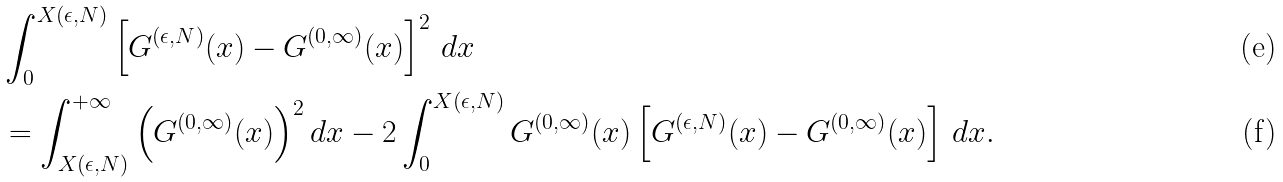<formula> <loc_0><loc_0><loc_500><loc_500>& \int _ { 0 } ^ { X ( \epsilon , N ) } \left [ G ^ { ( \epsilon , N ) } ( x ) - G ^ { ( 0 , \infty ) } ( x ) \right ] ^ { 2 } \, d x \\ & = \int _ { X ( \epsilon , N ) } ^ { + \infty } \left ( G ^ { ( 0 , \infty ) } ( x ) \right ) ^ { 2 } d x - 2 \int _ { 0 } ^ { X ( \epsilon , N ) } G ^ { ( 0 , \infty ) } ( x ) \left [ G ^ { ( \epsilon , N ) } ( x ) - G ^ { ( 0 , \infty ) } ( x ) \right ] \, d x .</formula> 